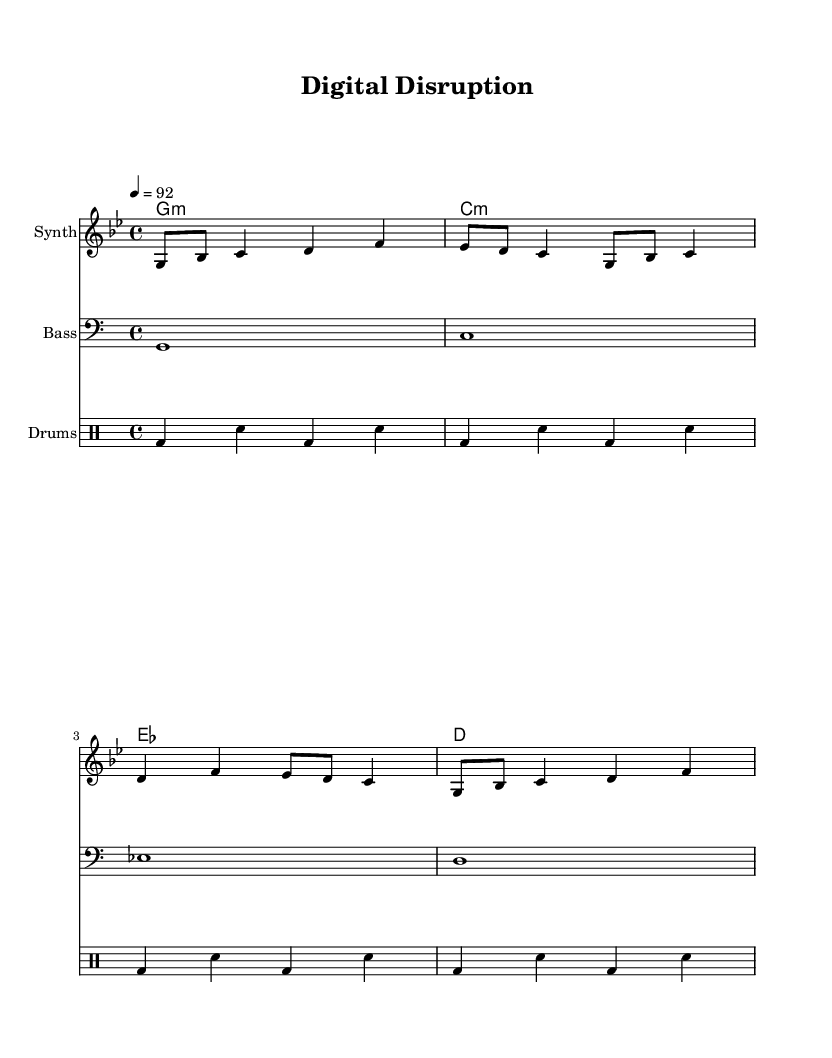What is the key signature of this music? The key signature is identified by looking at the beginning of the staff. Here it indicates G minor, which is represented by two flats (B flat and E flat).
Answer: G minor What is the time signature of this music? The time signature can be found at the beginning of the music sheet. It shows 4/4, meaning there are four beats in each measure and the quarter note gets one beat.
Answer: 4/4 What is the tempo marking in this piece? The tempo marking is indicated near the beginning of the score, stating the beats per minute. In this case, it is set at 92 beats per minute.
Answer: 92 How many measures are there in the melody? To find the number of measures, count how many times there is a bar line in the melody section. In this score, there are four measures for the melody.
Answer: 4 What type of drums are used in this piece? The drum notation starts with the designation ‘drummode’ in the score. The pattern indicates the use of a bass drum and snare, which are typical in hip-hop.
Answer: Bass drum and snare How does the harmony change throughout the piece? The harmonies are listed in chord mode and show the progression from G minor to C minor, then E flat major, and finally D major. The progression suggests a movement that is common in hip-hop tracks.
Answer: G minor to C minor to E flat major to D major What instruments are indicated in this music? The instruments are named above their respective staffs: Synth for the melody, Bass for the bass line, and Drums for the percussion part. Each section is clearly labeled.
Answer: Synth, Bass, Drums 